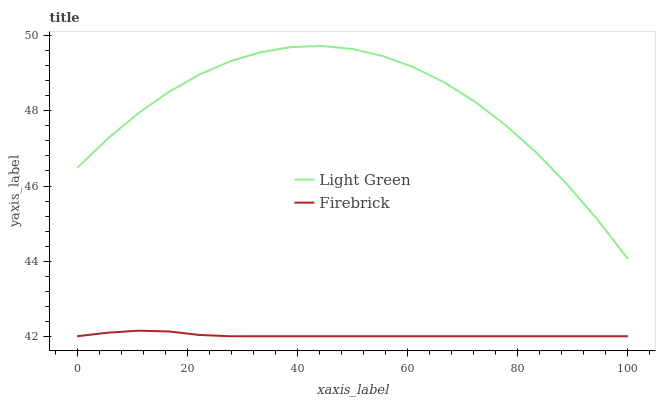Does Firebrick have the minimum area under the curve?
Answer yes or no. Yes. Does Light Green have the maximum area under the curve?
Answer yes or no. Yes. Does Light Green have the minimum area under the curve?
Answer yes or no. No. Is Firebrick the smoothest?
Answer yes or no. Yes. Is Light Green the roughest?
Answer yes or no. Yes. Is Light Green the smoothest?
Answer yes or no. No. Does Firebrick have the lowest value?
Answer yes or no. Yes. Does Light Green have the lowest value?
Answer yes or no. No. Does Light Green have the highest value?
Answer yes or no. Yes. Is Firebrick less than Light Green?
Answer yes or no. Yes. Is Light Green greater than Firebrick?
Answer yes or no. Yes. Does Firebrick intersect Light Green?
Answer yes or no. No. 